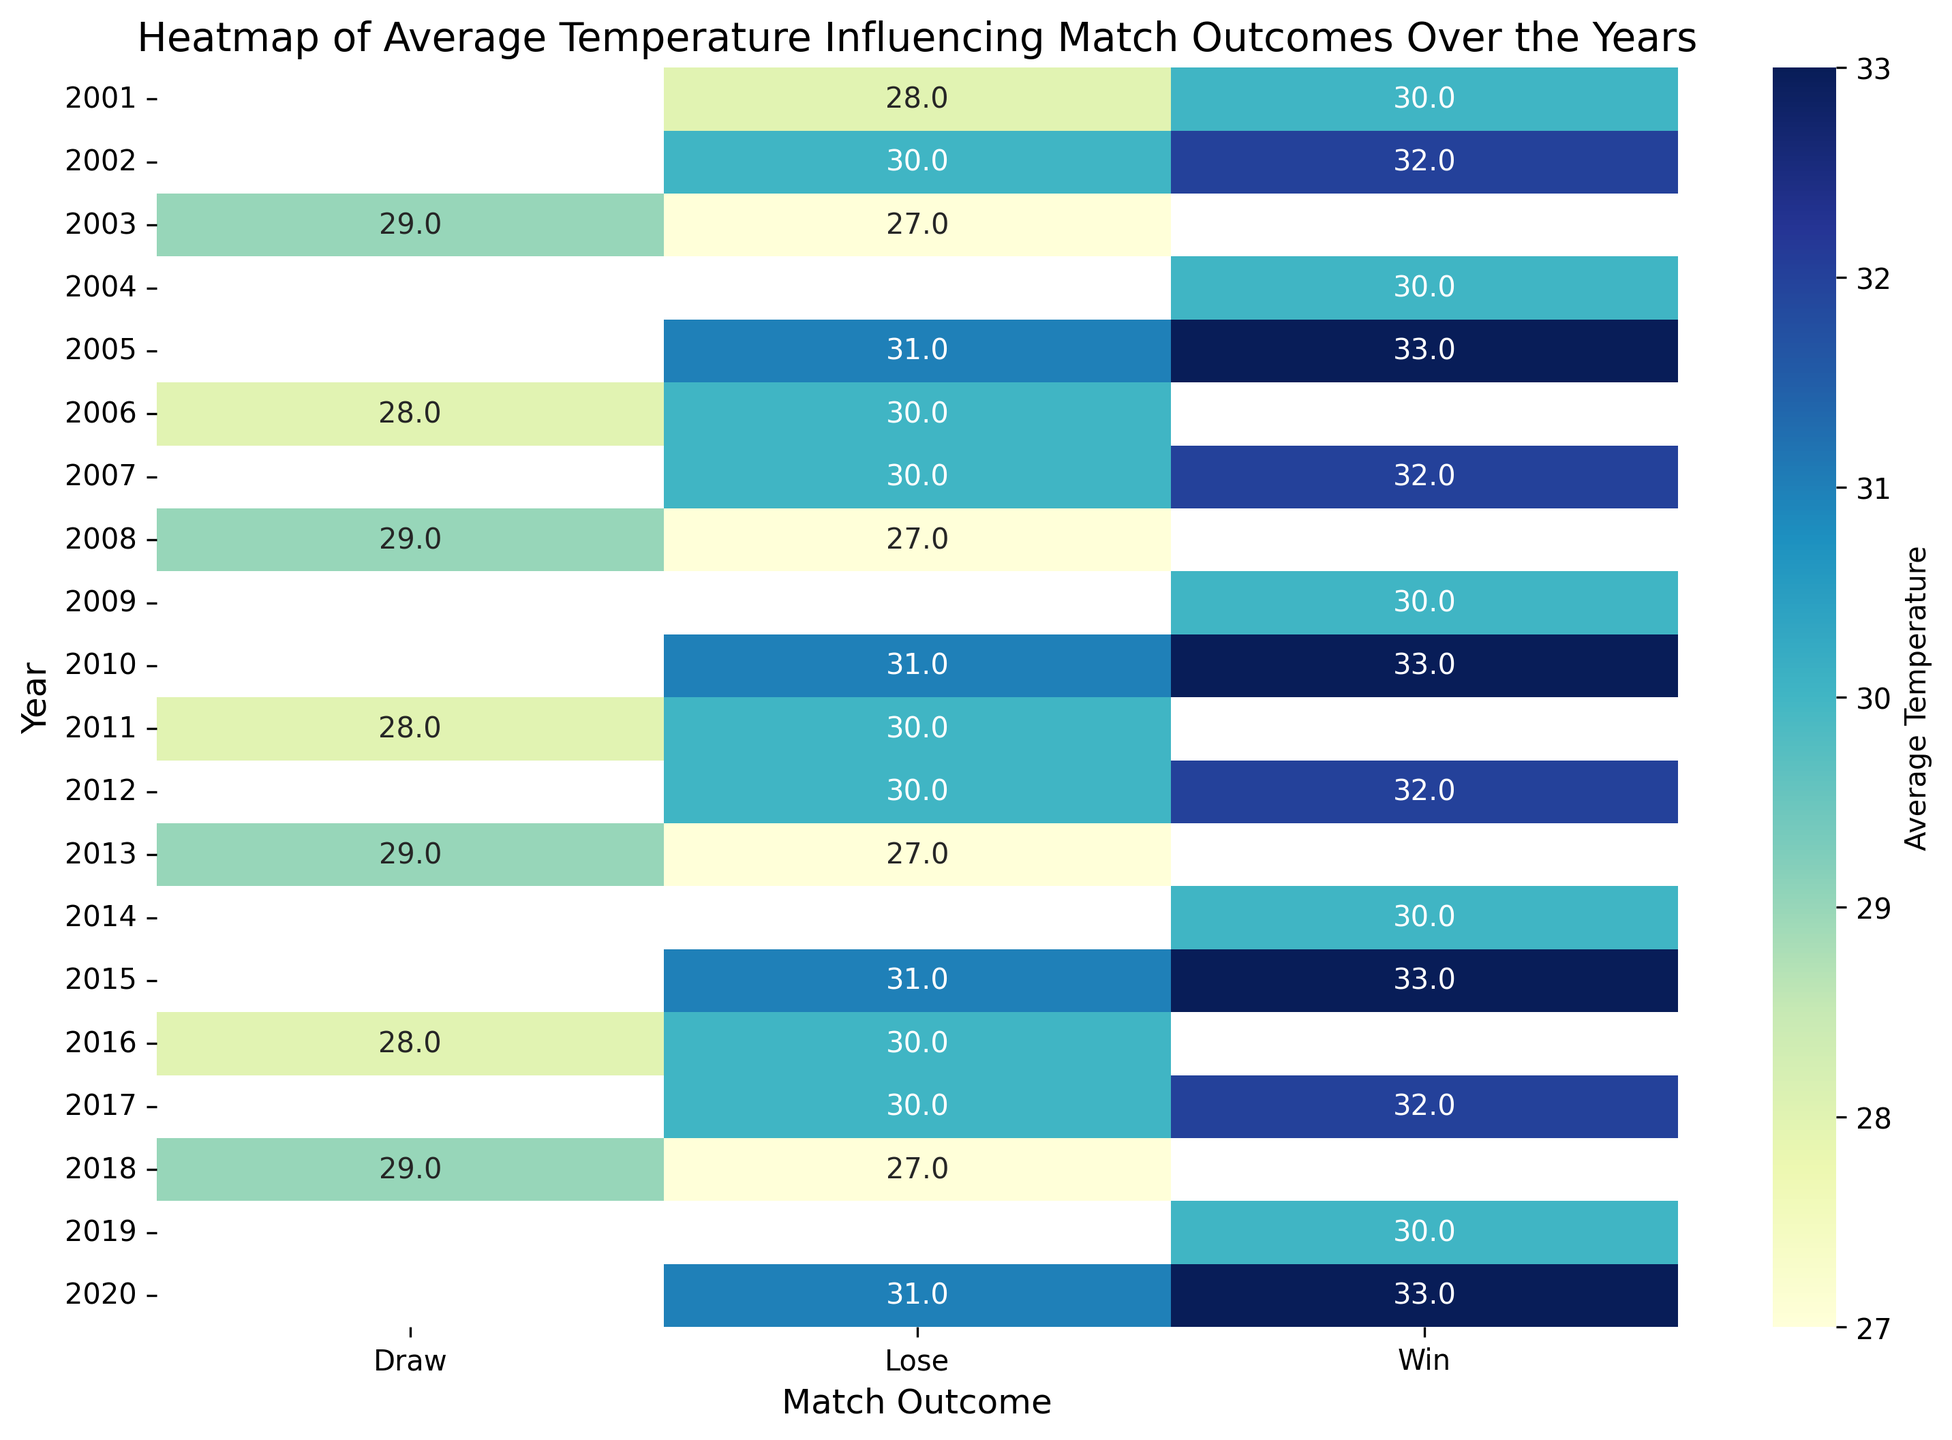What is the average temperature for the "Win" outcome in 2015? Locate 2015 in the heatmap row, then find the "Win" column for that year. The temperature value displayed in the corresponding cell is the average temperature.
Answer: 33.0 Which year had the highest average temperature for "Lose" outcomes? Scan the "Lose" column and identify the cell with the highest temperature value. Then, note the corresponding year.
Answer: 2011 In which year was the difference between the average temperatures for "Win" and "Lose" outcomes the largest? For each year, compute the absolute difference between "Win" and "Lose" temperature values, then compare these differences to identify the largest one.
Answer: 2010 Do "Win" outcomes generally occur at higher or lower average temperatures compared to "Lose" outcomes? Compare the general trend of temperature values in the "Win" column with those in the "Lose" column across the years.
Answer: Higher How does the average temperature for "Draw" outcomes in 2003 compare to "Win" outcomes in the same year? Locate the row for 2003, then compare the temperature values in the "Draw" and "Win" columns.
Answer: Lower for "Draw" Which year had equal average temperatures for "Win" and "Draw" outcomes? Scan the heatmap to find any year where the temperature values in the "Win" and "Draw" columns are the same.
Answer: None What is the range of average temperatures for "Lose" outcomes from 2001 to 2020? Identify the minimum and maximum temperature values in the "Lose" column, then calculate the range (max - min).
Answer: 27.0 Is there a visual trend showing which outcome has the most consistent temperature values over the years? Observe the consistency of the colors within each outcome column across the years. Consistent color shades suggest consistent temperature values.
Answer: "Win" Do you notice any visual pattern in the temperature values for "Draw" outcomes over the years? Look at the color gradient in the "Draw" column over the years to identify any patterns, such as consistent shading or variation.
Answer: Varies, with no consistent pattern What is the maximum average temperature observed for "Draw" outcomes, and in which year did it occur? Scan the "Draw" column for the highest temperature value, then check the corresponding year.
Answer: 2006, 28.0 